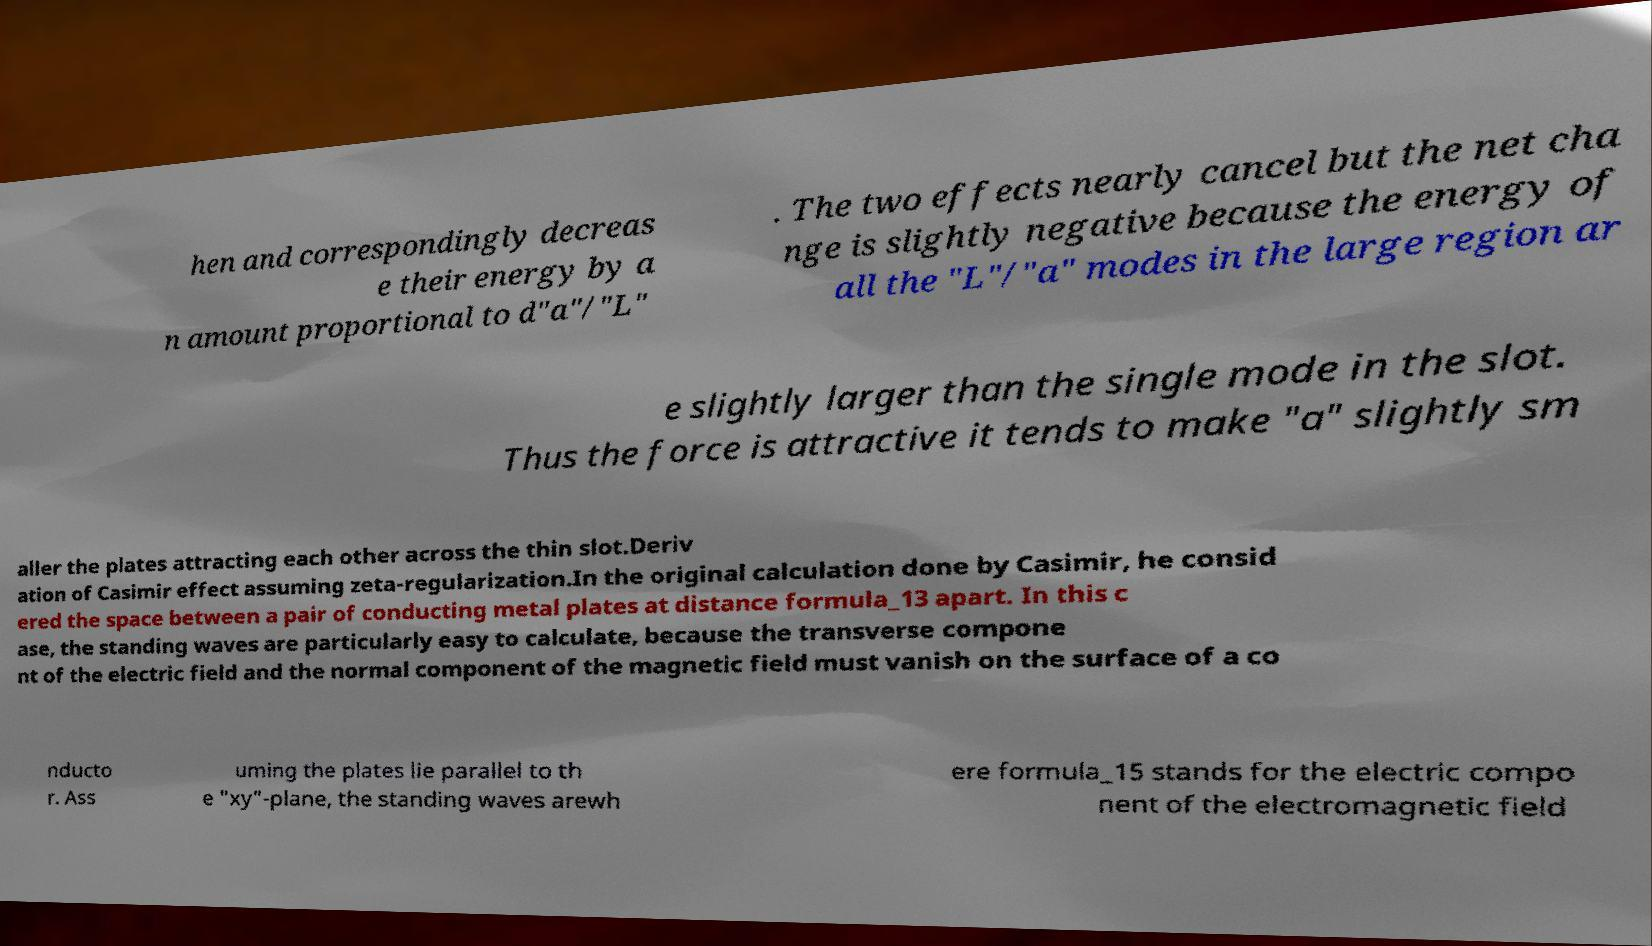Can you accurately transcribe the text from the provided image for me? hen and correspondingly decreas e their energy by a n amount proportional to d"a"/"L" . The two effects nearly cancel but the net cha nge is slightly negative because the energy of all the "L"/"a" modes in the large region ar e slightly larger than the single mode in the slot. Thus the force is attractive it tends to make "a" slightly sm aller the plates attracting each other across the thin slot.Deriv ation of Casimir effect assuming zeta-regularization.In the original calculation done by Casimir, he consid ered the space between a pair of conducting metal plates at distance formula_13 apart. In this c ase, the standing waves are particularly easy to calculate, because the transverse compone nt of the electric field and the normal component of the magnetic field must vanish on the surface of a co nducto r. Ass uming the plates lie parallel to th e "xy"-plane, the standing waves arewh ere formula_15 stands for the electric compo nent of the electromagnetic field 